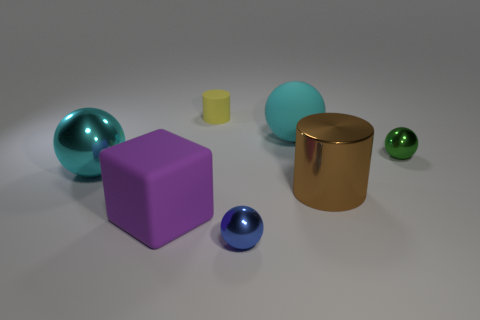There is a big metal ball; is it the same color as the big sphere on the right side of the blue metal ball?
Your answer should be very brief. Yes. How many other objects are there of the same color as the big metal cylinder?
Provide a short and direct response. 0. Are there fewer big purple rubber cubes than big red shiny blocks?
Your answer should be compact. No. There is a large brown metal cylinder right of the big cyan thing to the right of the small blue shiny ball; how many tiny spheres are on the right side of it?
Keep it short and to the point. 1. There is a shiny ball that is in front of the brown cylinder; what is its size?
Your answer should be compact. Small. Do the big cyan object that is on the left side of the yellow rubber thing and the green thing have the same shape?
Keep it short and to the point. Yes. There is another big cyan object that is the same shape as the big cyan shiny thing; what is its material?
Your answer should be compact. Rubber. Is there a tiny brown cylinder?
Make the answer very short. No. What material is the large cyan ball that is on the left side of the tiny metallic sphere that is in front of the tiny metal ball that is behind the small blue thing made of?
Offer a terse response. Metal. There is a big brown shiny object; does it have the same shape as the cyan thing to the right of the blue metal object?
Provide a short and direct response. No. 